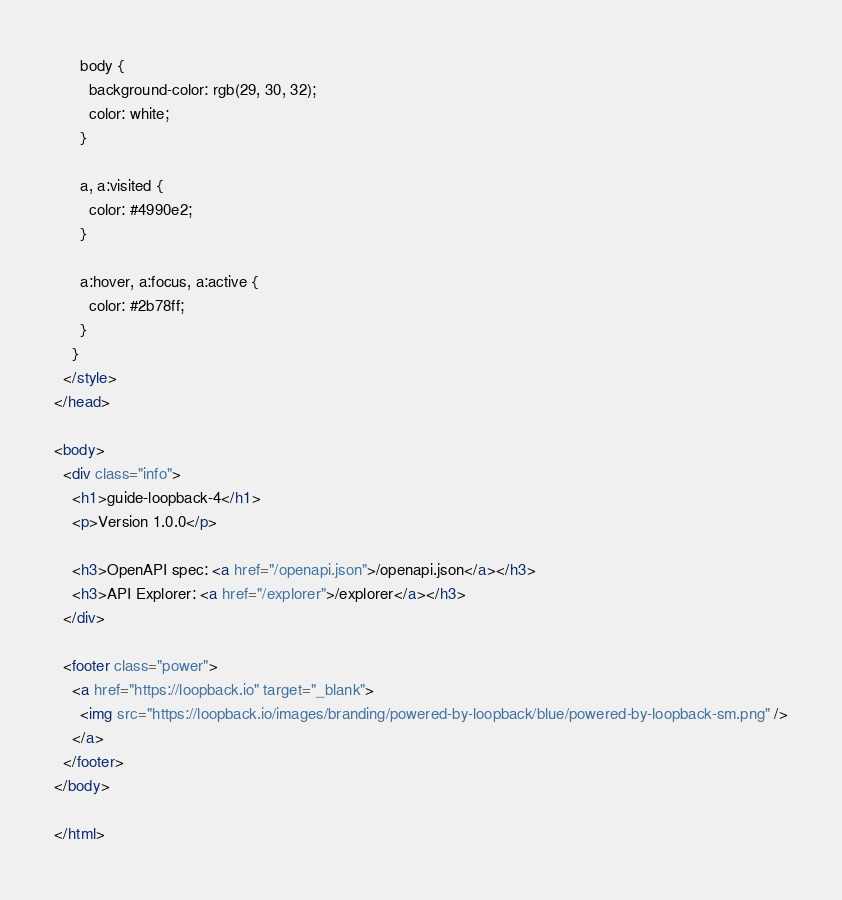<code> <loc_0><loc_0><loc_500><loc_500><_HTML_>      body {
        background-color: rgb(29, 30, 32);
        color: white;
      }

      a, a:visited {
        color: #4990e2;
      }

      a:hover, a:focus, a:active {
        color: #2b78ff;
      }
    }
  </style>
</head>

<body>
  <div class="info">
    <h1>guide-loopback-4</h1>
    <p>Version 1.0.0</p>

    <h3>OpenAPI spec: <a href="/openapi.json">/openapi.json</a></h3>
    <h3>API Explorer: <a href="/explorer">/explorer</a></h3>
  </div>

  <footer class="power">
    <a href="https://loopback.io" target="_blank">
      <img src="https://loopback.io/images/branding/powered-by-loopback/blue/powered-by-loopback-sm.png" />
    </a>
  </footer>
</body>

</html>
</code> 